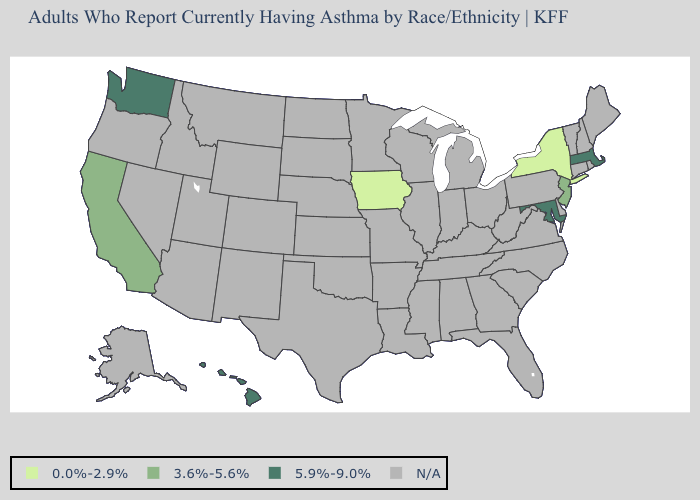Does New Jersey have the highest value in the Northeast?
Be succinct. No. Which states have the lowest value in the USA?
Write a very short answer. Iowa, New York. What is the value of Delaware?
Short answer required. N/A. What is the value of Montana?
Write a very short answer. N/A. Name the states that have a value in the range N/A?
Concise answer only. Alabama, Alaska, Arizona, Arkansas, Colorado, Connecticut, Delaware, Florida, Georgia, Idaho, Illinois, Indiana, Kansas, Kentucky, Louisiana, Maine, Michigan, Minnesota, Mississippi, Missouri, Montana, Nebraska, Nevada, New Hampshire, New Mexico, North Carolina, North Dakota, Ohio, Oklahoma, Oregon, Pennsylvania, Rhode Island, South Carolina, South Dakota, Tennessee, Texas, Utah, Vermont, Virginia, West Virginia, Wisconsin, Wyoming. Name the states that have a value in the range 5.9%-9.0%?
Concise answer only. Hawaii, Maryland, Massachusetts, Washington. What is the value of Louisiana?
Give a very brief answer. N/A. What is the value of Idaho?
Concise answer only. N/A. What is the lowest value in the South?
Write a very short answer. 5.9%-9.0%. Is the legend a continuous bar?
Write a very short answer. No. Which states have the highest value in the USA?
Write a very short answer. Hawaii, Maryland, Massachusetts, Washington. 